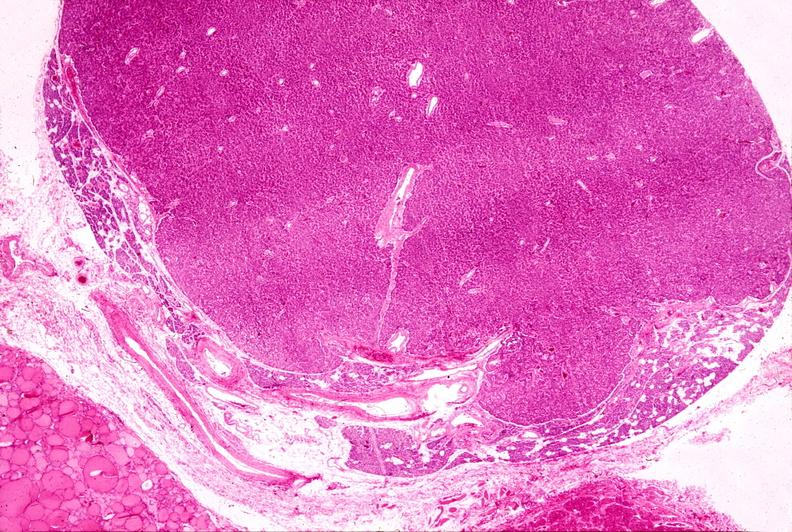s endocrine present?
Answer the question using a single word or phrase. Yes 